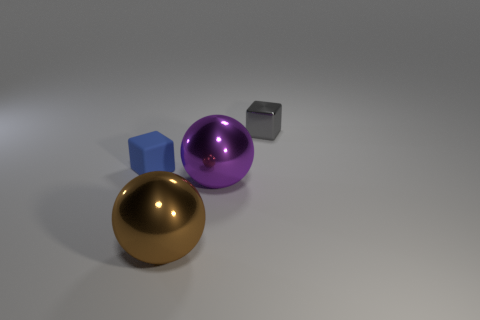Do the objects look like they're part of a real environment or a digital rendering? The objects in the image appear to be part of a digital rendering rather than a real environment. This is suggested by the impeccable smoothness of the surfaces, the precise shadows, and the uniform background, which are characteristic of computer-generated imagery. 